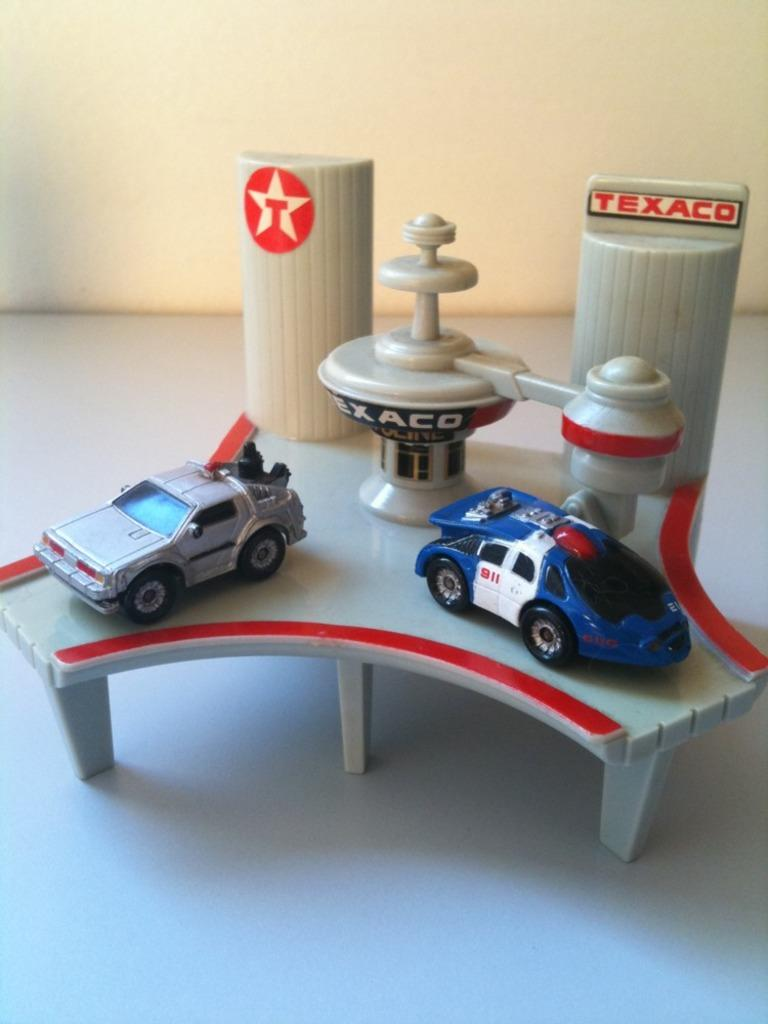What type of objects are present in the image? The image contains toys. Can you describe the specific toys in the image? There are two cars in the front of the image. What is visible at the bottom of the image? There is a floor visible at the bottom of the image. What can be seen in the background of the image? There is a wall in the background of the image. What type of ticket is required to attend the meeting in the image? There is no meeting or ticket present in the image; it contains toys, specifically two cars. 